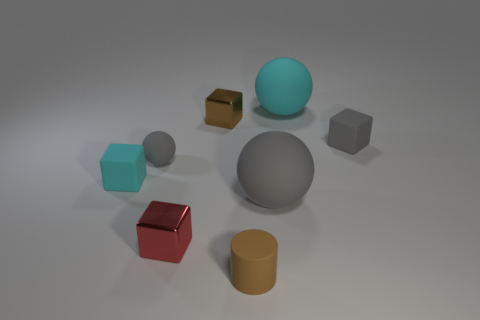Subtract all gray blocks. How many blocks are left? 3 Add 2 large brown matte cubes. How many objects exist? 10 Subtract 1 balls. How many balls are left? 2 Subtract all cyan blocks. How many blocks are left? 3 Subtract all gray cubes. Subtract all red balls. How many cubes are left? 3 Subtract all cylinders. How many objects are left? 7 Subtract 0 blue cubes. How many objects are left? 8 Subtract all tiny blocks. Subtract all brown matte cylinders. How many objects are left? 3 Add 4 gray cubes. How many gray cubes are left? 5 Add 3 big gray rubber things. How many big gray rubber things exist? 4 